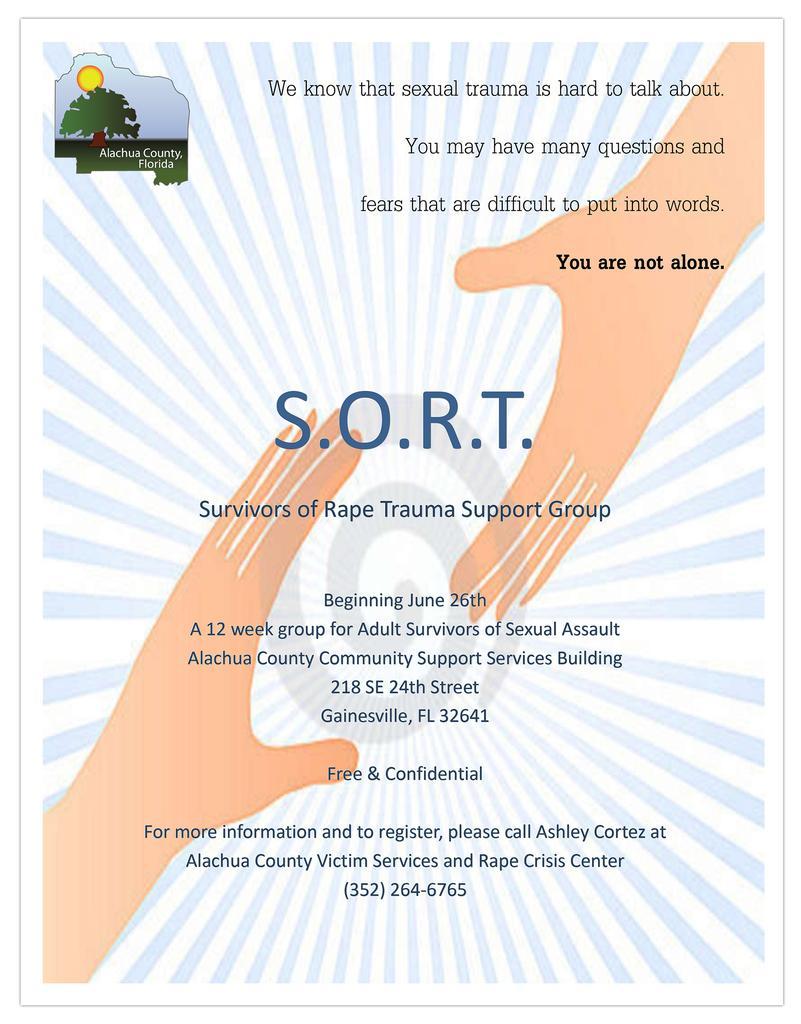Please provide a concise description of this image. This is a poster and we can see logo, watermark and texts written on it. We can also see picture of hands of a person on it. 